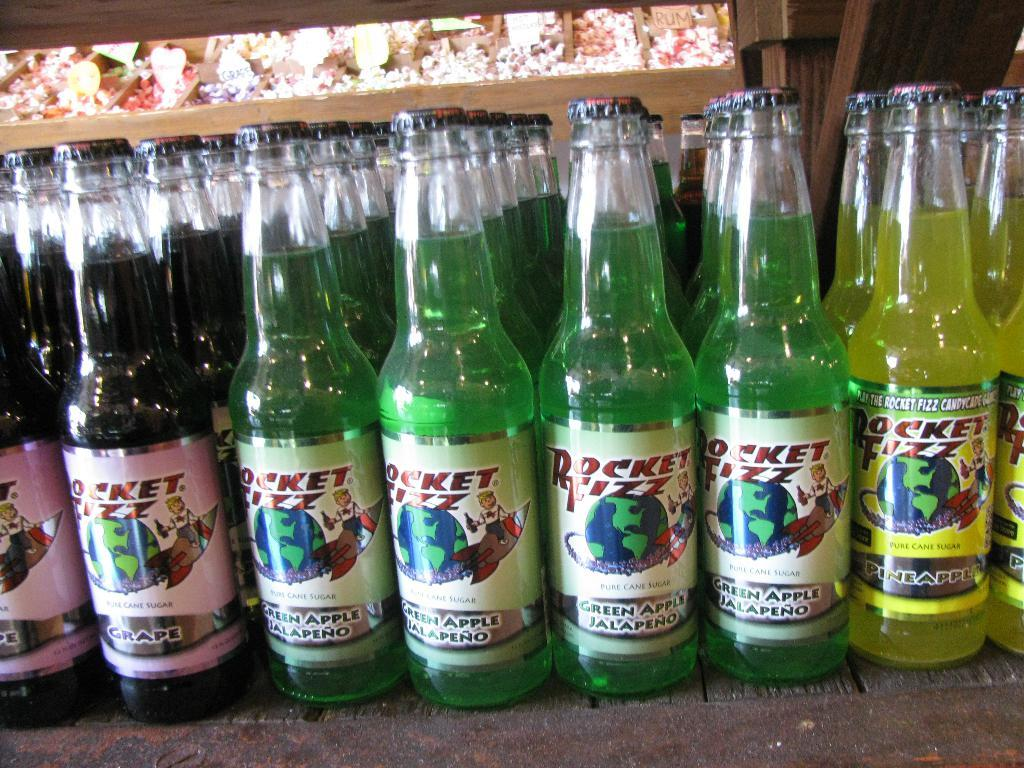<image>
Provide a brief description of the given image. Bottles of Rocket Fizz soda have strange names. 